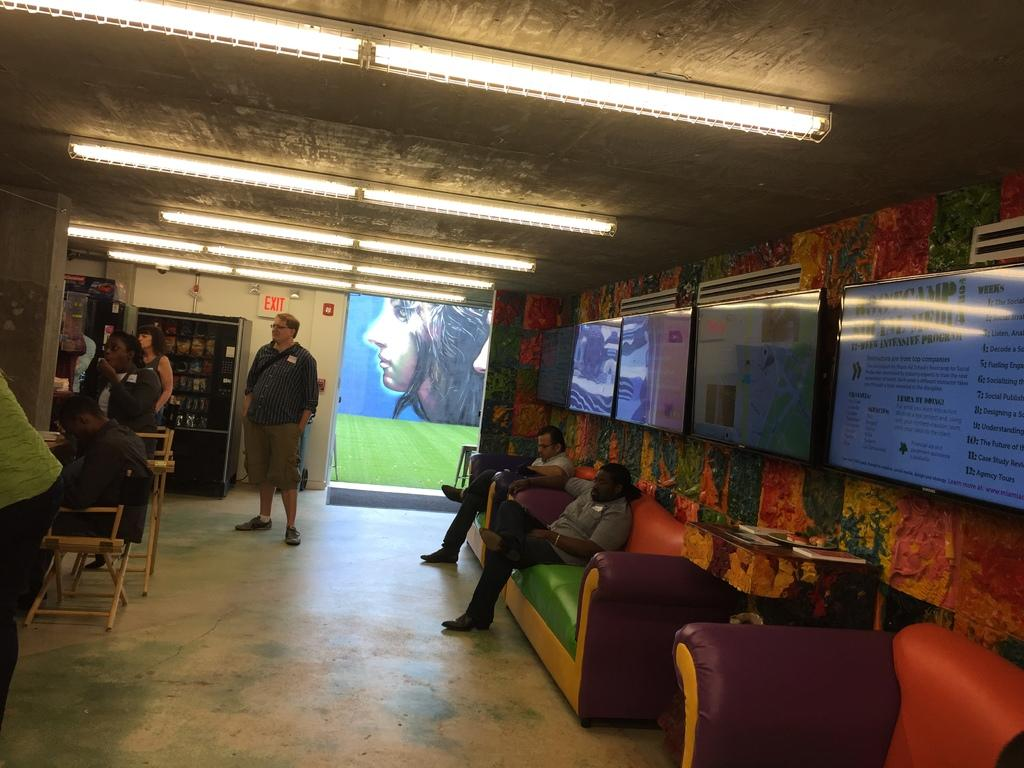What are the people in the image doing? There are people sitting in the sofas and some people are standing. What can be seen on the right side of the image? There are televisions attached to the wall on the right side. What is visible in the background of the image? There is a wall and a shelf in the background. What type of arithmetic problem is being solved on the bridge in the image? There is no bridge or arithmetic problem present in the image. What kind of food is being served on the shelf in the background? There is no food visible on the shelf in the background; it is a shelf with unspecified items. 